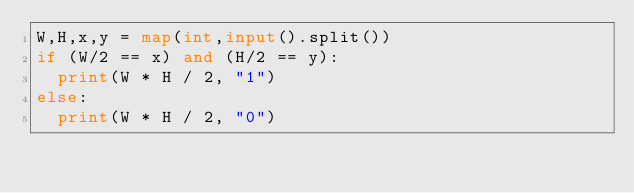Convert code to text. <code><loc_0><loc_0><loc_500><loc_500><_Python_>W,H,x,y = map(int,input().split())
if (W/2 == x) and (H/2 == y):
  print(W * H / 2, "1")
else:
  print(W * H / 2, "0")
  </code> 